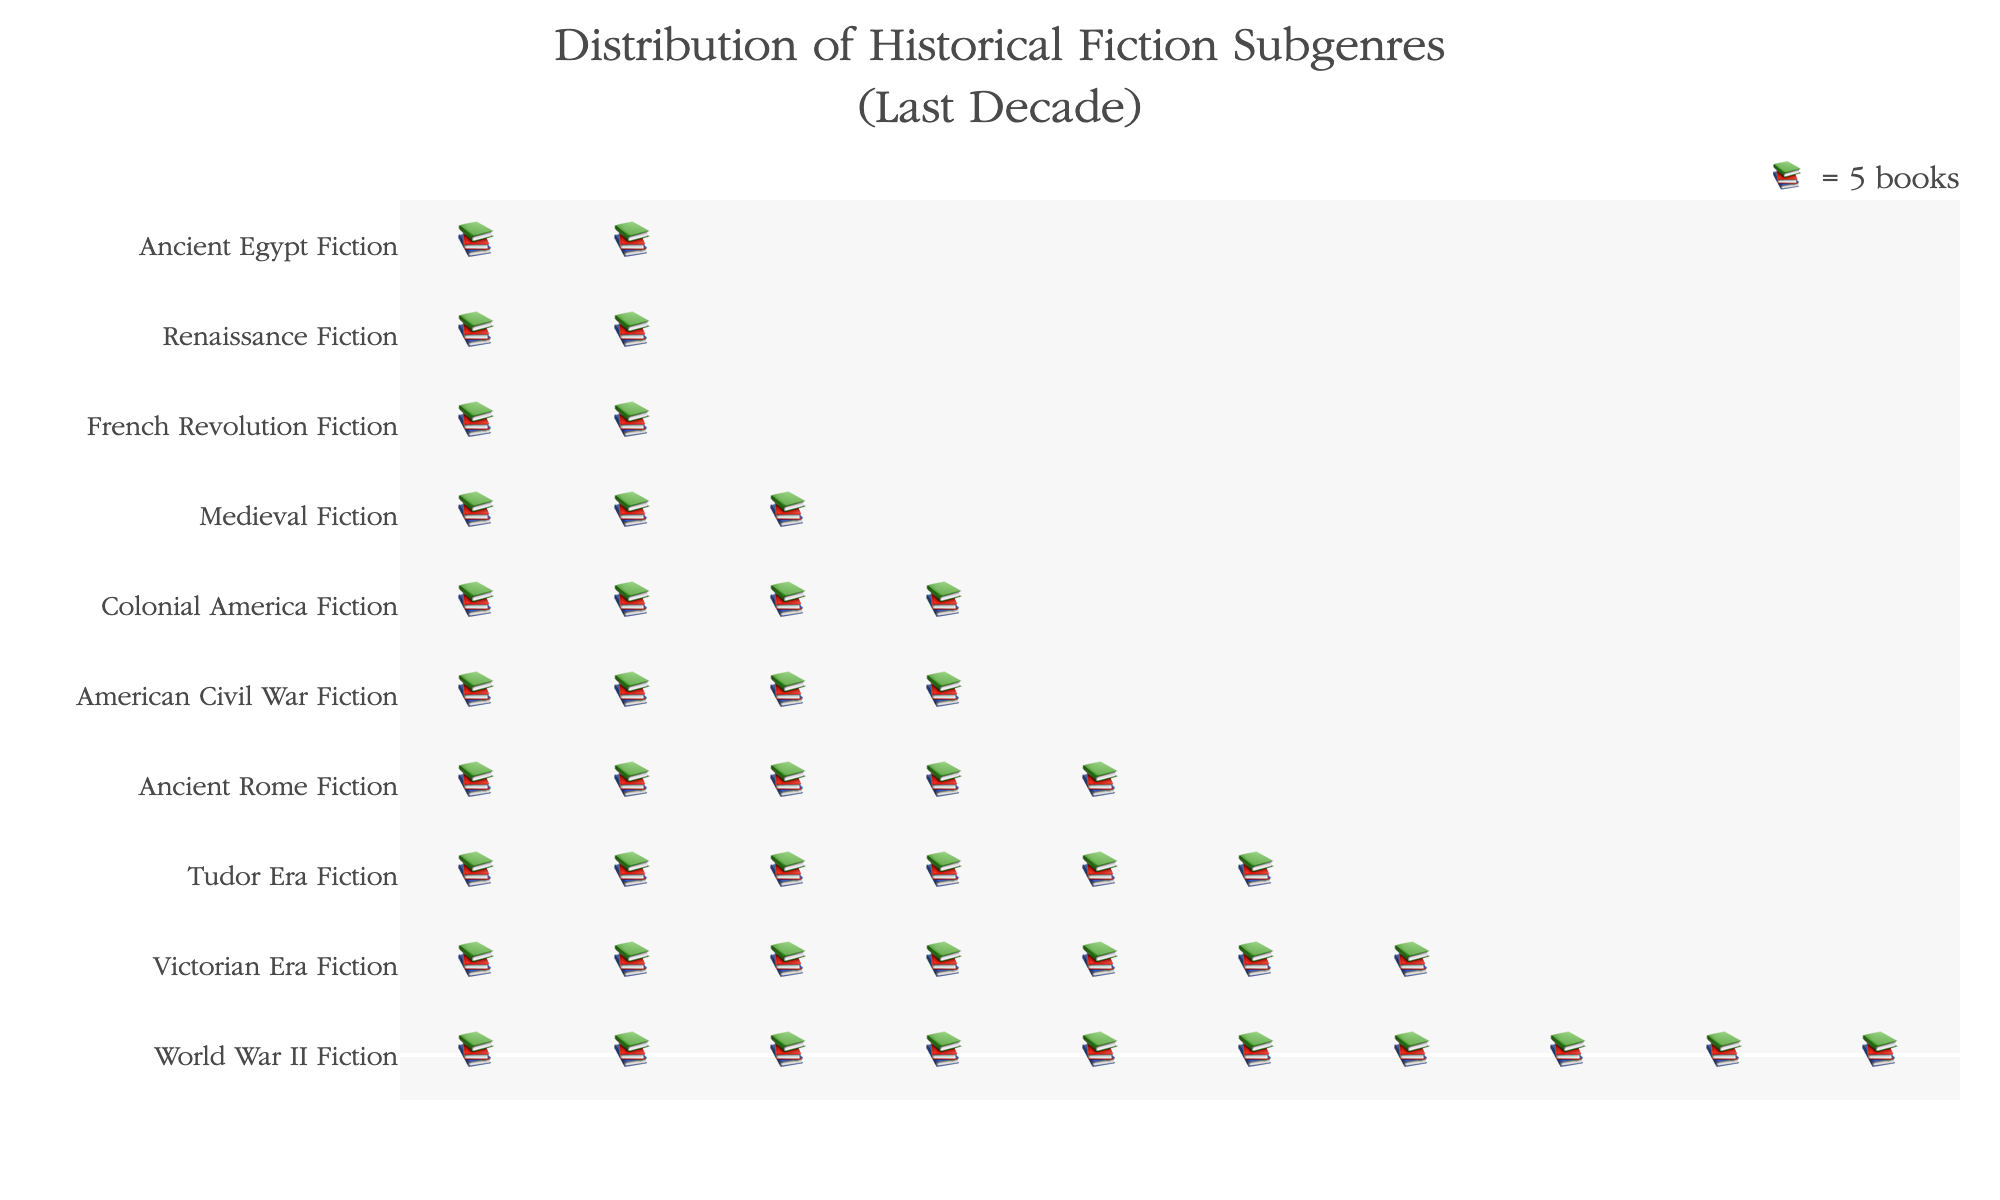What is the total number of subgenres shown in the plot? Count the distinct subgenres listed on the y-axis.
Answer: 10 Which subgenre has the highest number of books published? Look for the subgenre corresponding to the highest number of icons (books) in the plot.
Answer: World War II Fiction How many books were published in the American Civil War Fiction subgenre? Count the icons on the y-axis next to "American Civil War Fiction" and multiply by 5, as each icon represents 5 books.
Answer: 20 Which two subgenres have the smallest number of books published? Identify the two subgenres with the fewest icons next to their names.
Answer: Ancient Egypt Fiction, Renaissance Fiction By how much does the Tudor Era Fiction subgenre exceed the American Civil War Fiction subgenre in the number of books published? Calculate the difference in the number of icons for the two subgenres and multiply by 5. (30 books - 20 books)
Answer: 10 What's the total number of books published in the top three subgenres combined? Find the total number of icons for the top three subgenres and multiply by 5. (50 books + 35 books + 30 books)
Answer: 115 Compare the number of books published in the Victorian Era Fiction subgenre to the Renaissance Fiction subgenre. Which is greater and by how much? Identify the number of icons for both subgenres, subtract the number of icons for Renaissance from Victorian, and multiply by 5. Victorian Era Fiction (35) - Renaissance Fiction (10) = 25
Answer: Victorian Era Fiction, 25 What subgenre has exactly 12 books published? Look for the subgenre with exactly 2 icons next to it, as each icon represents 5 books.
Answer: French Revolution Fiction Add up the total number of books published across all subgenres shown. Sum the number of books published for each subgenre. 50 + 30 + 25 + 20 + 35 + 15 + 10 + 18 + 12 + 8 = 223
Answer: 223 How many more books were published in the Tudor Era Fiction subgenre compared to the Ancient Rome Fiction subgenre? Calculate the difference in the number of books published between the two subgenres. (30 books - 25 books)
Answer: 5 